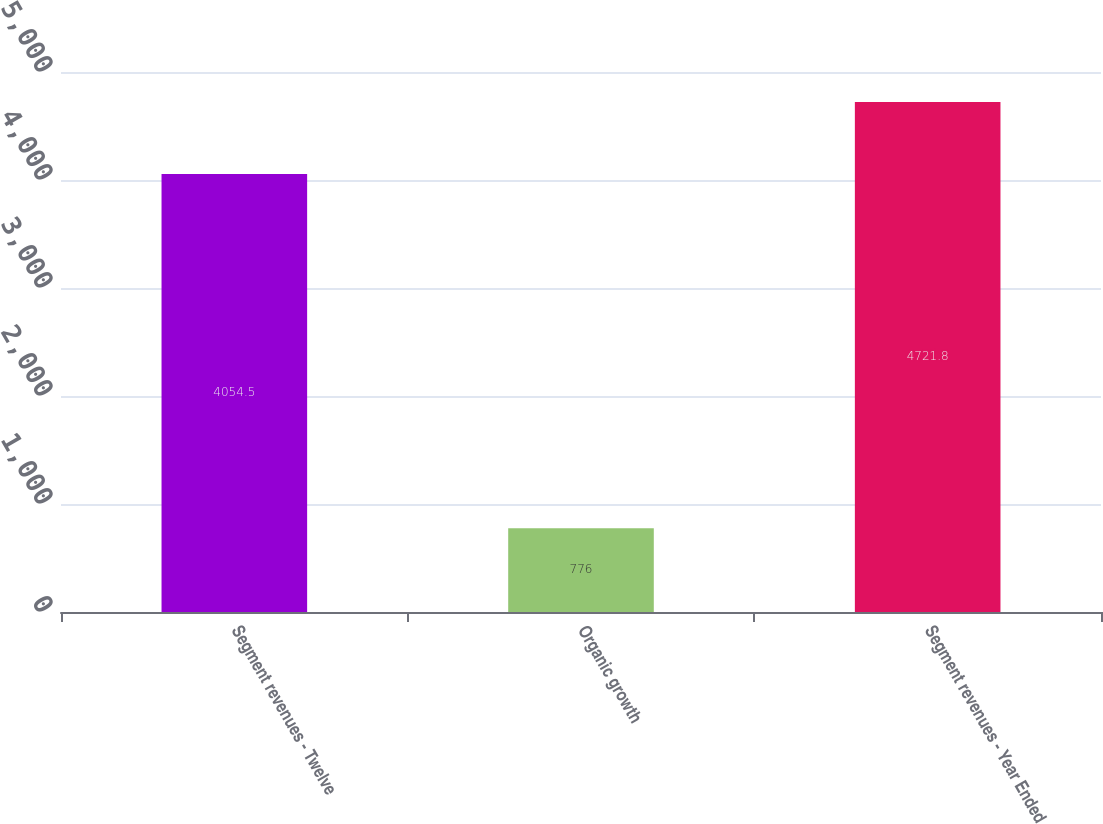Convert chart. <chart><loc_0><loc_0><loc_500><loc_500><bar_chart><fcel>Segment revenues - Twelve<fcel>Organic growth<fcel>Segment revenues - Year Ended<nl><fcel>4054.5<fcel>776<fcel>4721.8<nl></chart> 